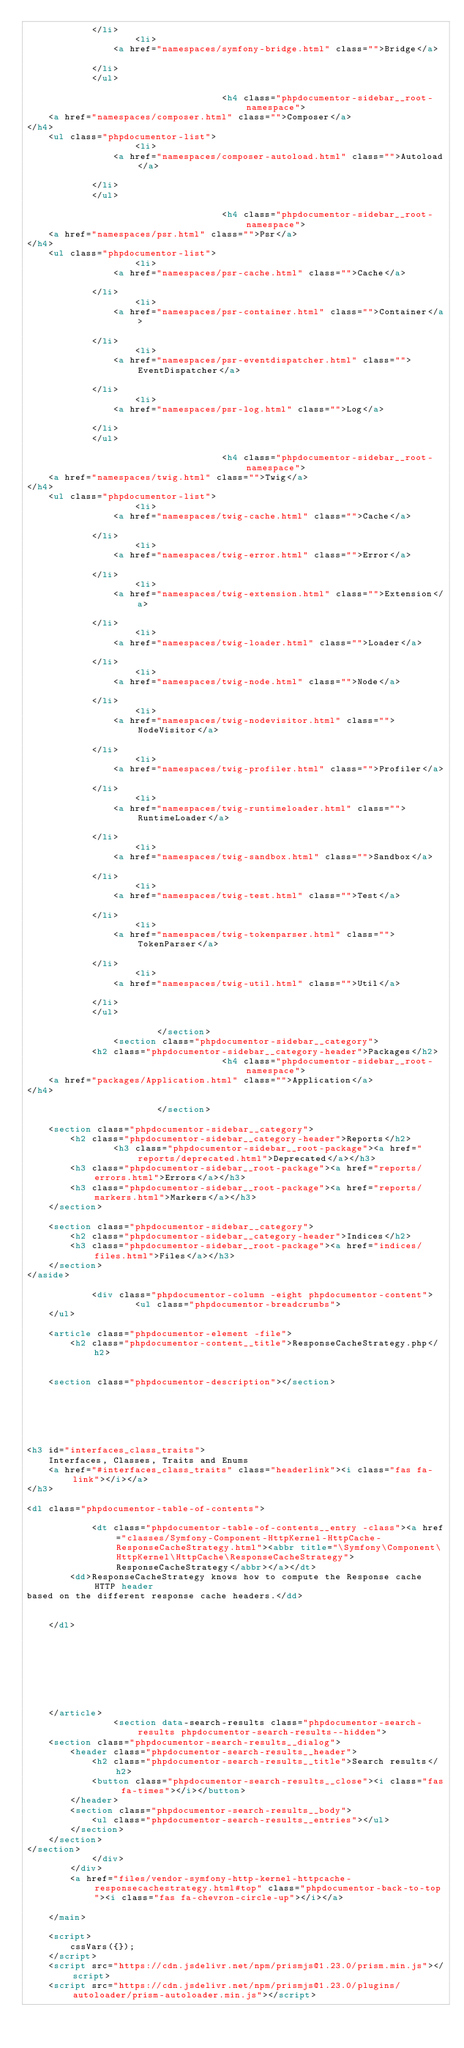<code> <loc_0><loc_0><loc_500><loc_500><_HTML_>            </li>
                    <li>
                <a href="namespaces/symfony-bridge.html" class="">Bridge</a>
                
            </li>
            </ul>

                                    <h4 class="phpdocumentor-sidebar__root-namespace">
    <a href="namespaces/composer.html" class="">Composer</a>
</h4>
    <ul class="phpdocumentor-list">
                    <li>
                <a href="namespaces/composer-autoload.html" class="">Autoload</a>
                
            </li>
            </ul>

                                    <h4 class="phpdocumentor-sidebar__root-namespace">
    <a href="namespaces/psr.html" class="">Psr</a>
</h4>
    <ul class="phpdocumentor-list">
                    <li>
                <a href="namespaces/psr-cache.html" class="">Cache</a>
                
            </li>
                    <li>
                <a href="namespaces/psr-container.html" class="">Container</a>
                
            </li>
                    <li>
                <a href="namespaces/psr-eventdispatcher.html" class="">EventDispatcher</a>
                
            </li>
                    <li>
                <a href="namespaces/psr-log.html" class="">Log</a>
                
            </li>
            </ul>

                                    <h4 class="phpdocumentor-sidebar__root-namespace">
    <a href="namespaces/twig.html" class="">Twig</a>
</h4>
    <ul class="phpdocumentor-list">
                    <li>
                <a href="namespaces/twig-cache.html" class="">Cache</a>
                
            </li>
                    <li>
                <a href="namespaces/twig-error.html" class="">Error</a>
                
            </li>
                    <li>
                <a href="namespaces/twig-extension.html" class="">Extension</a>
                
            </li>
                    <li>
                <a href="namespaces/twig-loader.html" class="">Loader</a>
                
            </li>
                    <li>
                <a href="namespaces/twig-node.html" class="">Node</a>
                
            </li>
                    <li>
                <a href="namespaces/twig-nodevisitor.html" class="">NodeVisitor</a>
                
            </li>
                    <li>
                <a href="namespaces/twig-profiler.html" class="">Profiler</a>
                
            </li>
                    <li>
                <a href="namespaces/twig-runtimeloader.html" class="">RuntimeLoader</a>
                
            </li>
                    <li>
                <a href="namespaces/twig-sandbox.html" class="">Sandbox</a>
                
            </li>
                    <li>
                <a href="namespaces/twig-test.html" class="">Test</a>
                
            </li>
                    <li>
                <a href="namespaces/twig-tokenparser.html" class="">TokenParser</a>
                
            </li>
                    <li>
                <a href="namespaces/twig-util.html" class="">Util</a>
                
            </li>
            </ul>

                        </section>
                <section class="phpdocumentor-sidebar__category">
            <h2 class="phpdocumentor-sidebar__category-header">Packages</h2>
                                    <h4 class="phpdocumentor-sidebar__root-namespace">
    <a href="packages/Application.html" class="">Application</a>
</h4>

                        </section>
            
    <section class="phpdocumentor-sidebar__category">
        <h2 class="phpdocumentor-sidebar__category-header">Reports</h2>
                <h3 class="phpdocumentor-sidebar__root-package"><a href="reports/deprecated.html">Deprecated</a></h3>
        <h3 class="phpdocumentor-sidebar__root-package"><a href="reports/errors.html">Errors</a></h3>
        <h3 class="phpdocumentor-sidebar__root-package"><a href="reports/markers.html">Markers</a></h3>
    </section>

    <section class="phpdocumentor-sidebar__category">
        <h2 class="phpdocumentor-sidebar__category-header">Indices</h2>
        <h3 class="phpdocumentor-sidebar__root-package"><a href="indices/files.html">Files</a></h3>
    </section>
</aside>

            <div class="phpdocumentor-column -eight phpdocumentor-content">
                    <ul class="phpdocumentor-breadcrumbs">
    </ul>

    <article class="phpdocumentor-element -file">
        <h2 class="phpdocumentor-content__title">ResponseCacheStrategy.php</h2>

        
    <section class="phpdocumentor-description"></section>






<h3 id="interfaces_class_traits">
    Interfaces, Classes, Traits and Enums
    <a href="#interfaces_class_traits" class="headerlink"><i class="fas fa-link"></i></a>
</h3>

<dl class="phpdocumentor-table-of-contents">
    
            <dt class="phpdocumentor-table-of-contents__entry -class"><a href="classes/Symfony-Component-HttpKernel-HttpCache-ResponseCacheStrategy.html"><abbr title="\Symfony\Component\HttpKernel\HttpCache\ResponseCacheStrategy">ResponseCacheStrategy</abbr></a></dt>
        <dd>ResponseCacheStrategy knows how to compute the Response cache HTTP header
based on the different response cache headers.</dd>
    
    
    </dl>





        

        
    </article>
                <section data-search-results class="phpdocumentor-search-results phpdocumentor-search-results--hidden">
    <section class="phpdocumentor-search-results__dialog">
        <header class="phpdocumentor-search-results__header">
            <h2 class="phpdocumentor-search-results__title">Search results</h2>
            <button class="phpdocumentor-search-results__close"><i class="fas fa-times"></i></button>
        </header>
        <section class="phpdocumentor-search-results__body">
            <ul class="phpdocumentor-search-results__entries"></ul>
        </section>
    </section>
</section>
            </div>
        </div>
        <a href="files/vendor-symfony-http-kernel-httpcache-responsecachestrategy.html#top" class="phpdocumentor-back-to-top"><i class="fas fa-chevron-circle-up"></i></a>

    </main>

    <script>
        cssVars({});
    </script>
    <script src="https://cdn.jsdelivr.net/npm/prismjs@1.23.0/prism.min.js"></script>
    <script src="https://cdn.jsdelivr.net/npm/prismjs@1.23.0/plugins/autoloader/prism-autoloader.min.js"></script></code> 